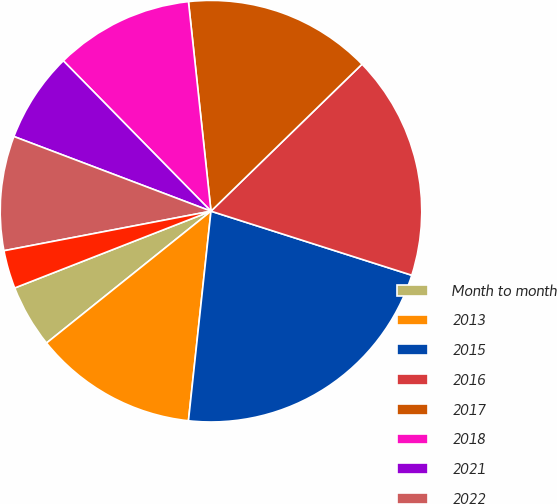<chart> <loc_0><loc_0><loc_500><loc_500><pie_chart><fcel>Month to month<fcel>2013<fcel>2015<fcel>2016<fcel>2017<fcel>2018<fcel>2021<fcel>2022<fcel>2014<nl><fcel>4.82%<fcel>12.54%<fcel>21.79%<fcel>17.2%<fcel>14.42%<fcel>10.65%<fcel>6.88%<fcel>8.77%<fcel>2.93%<nl></chart> 